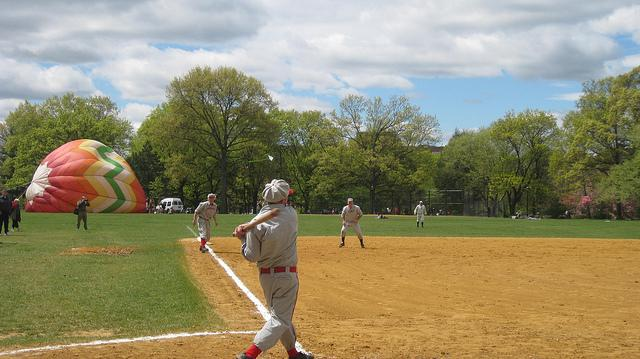What type of transport is visible here? balloon 